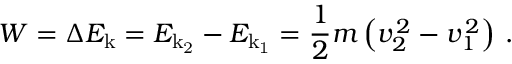Convert formula to latex. <formula><loc_0><loc_0><loc_500><loc_500>W = \Delta E _ { k } = E _ { k _ { 2 } } - E _ { k _ { 1 } } = { \frac { 1 } { 2 } } m \left ( v _ { 2 } ^ { \, 2 } - v _ { 1 } ^ { \, 2 } \right ) \, .</formula> 